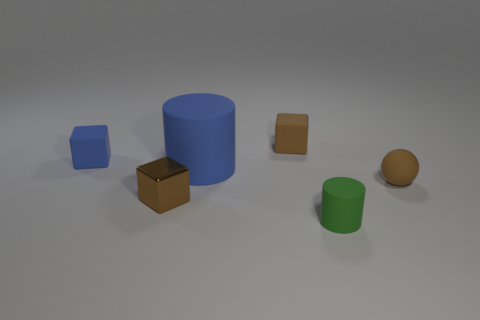Is the number of brown metallic objects behind the tiny sphere greater than the number of gray things? no 